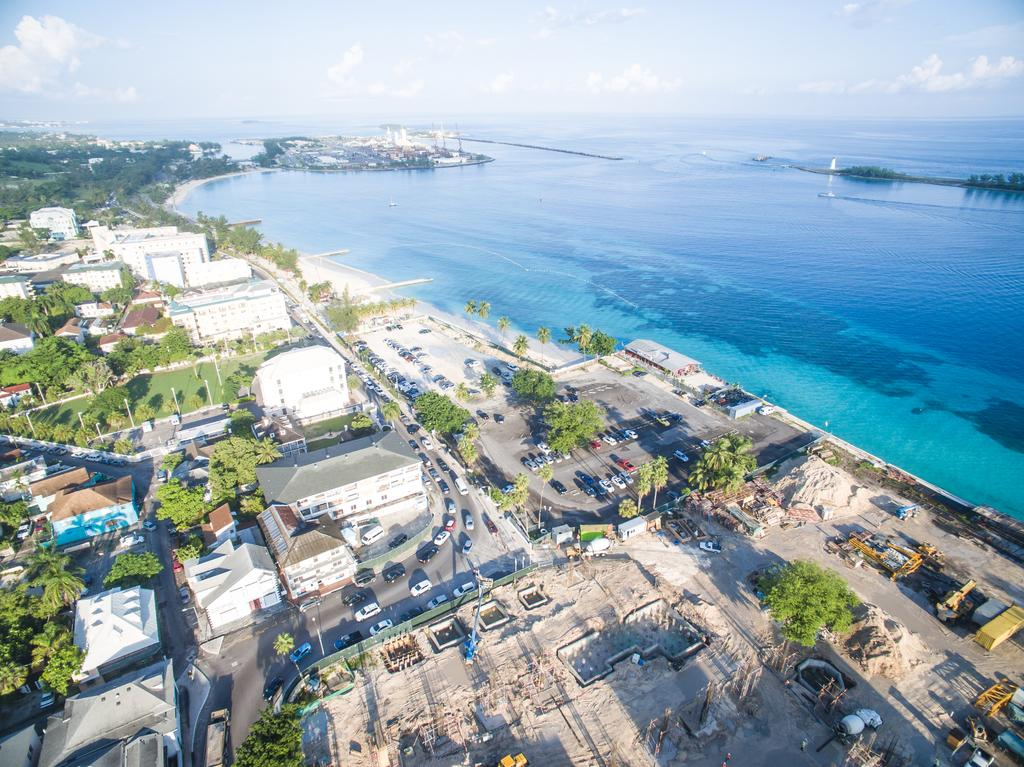What type of view is shown in the image? The image is an aerial view. What structures can be seen in the image? There are houses in the image. What type of vegetation is present in the image? There are trees in the image. What else can be seen moving around in the image? There are vehicles in the image. What are the vertical structures in the image? There are poles in the image. What natural element is visible in the image? There is water visible in the image. What is visible above the structures and vegetation in the image? The sky is visible in the image. How many bags can be seen floating on the water in the image? There are no bags visible in the image; it only shows an aerial view of houses, trees, vehicles, poles, water, and the sky. 